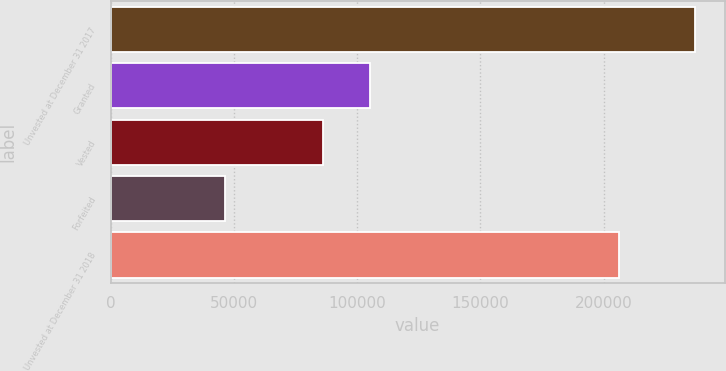<chart> <loc_0><loc_0><loc_500><loc_500><bar_chart><fcel>Unvested at December 31 2017<fcel>Granted<fcel>Vested<fcel>Forfeited<fcel>Unvested at December 31 2018<nl><fcel>237171<fcel>105372<fcel>86294<fcel>46391<fcel>206100<nl></chart> 